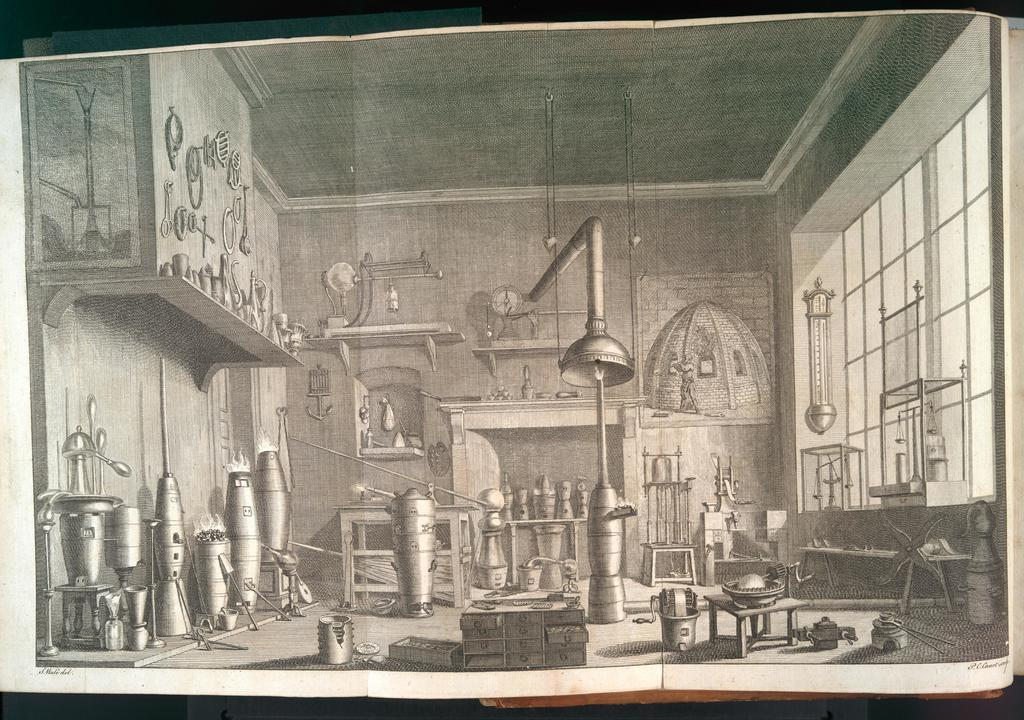What type of location is shown in the image? The image depicts a chemistry lab. What can be found in the lab? There are various equipment present in the lab. Is there any natural light source visible in the image? Yes, there is a window on the right side of the image. Can you hear the sound of a railway in the background of the image? There is no sound or reference to a railway in the image; it depicts a chemistry lab with various equipment and a window. 